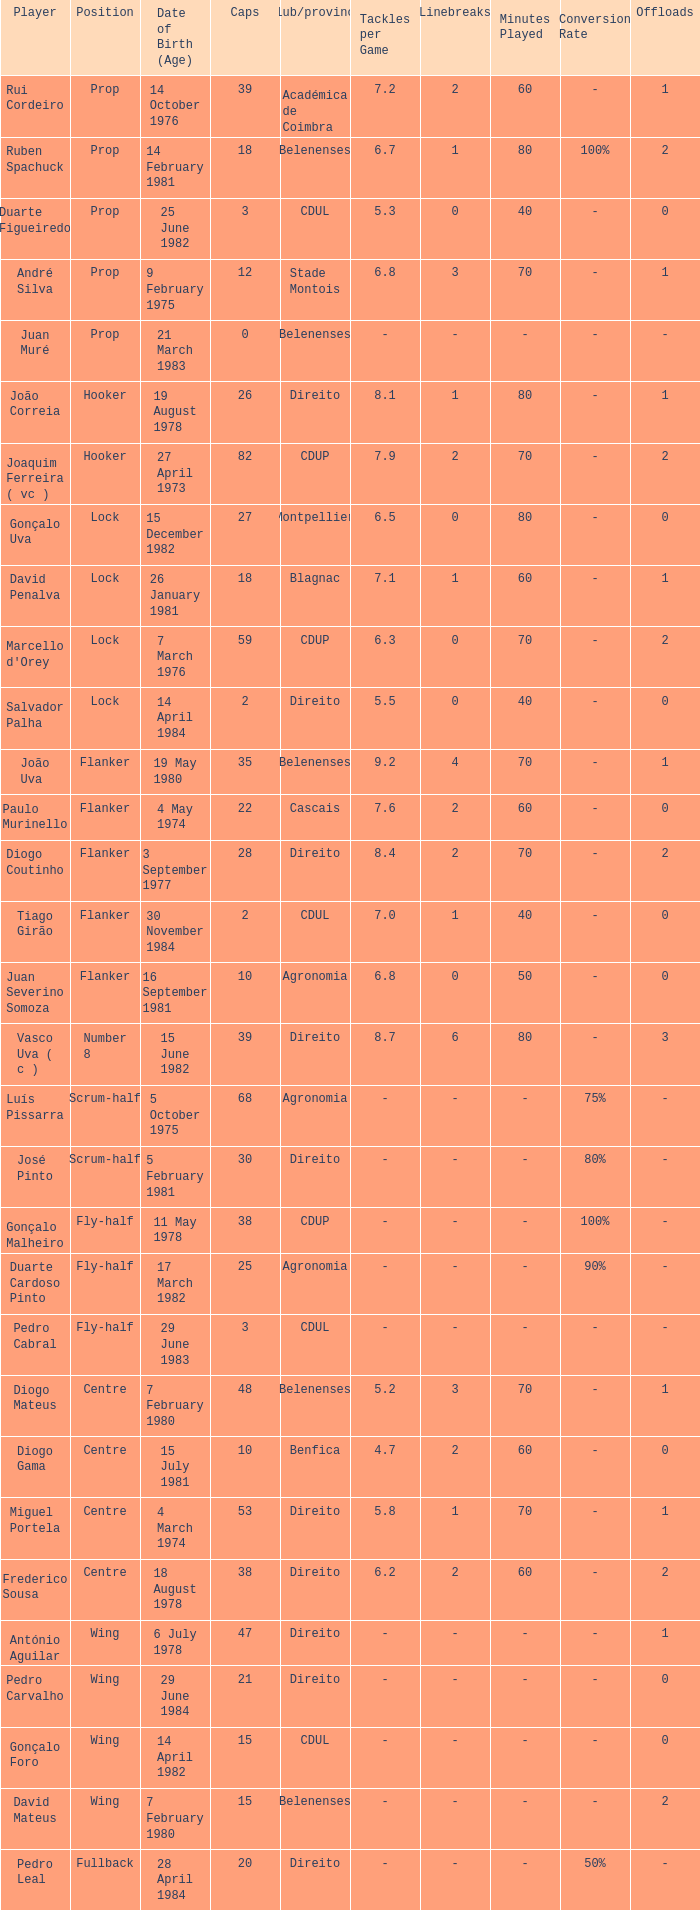How many caps have a Position of prop, and a Player of rui cordeiro? 1.0. 